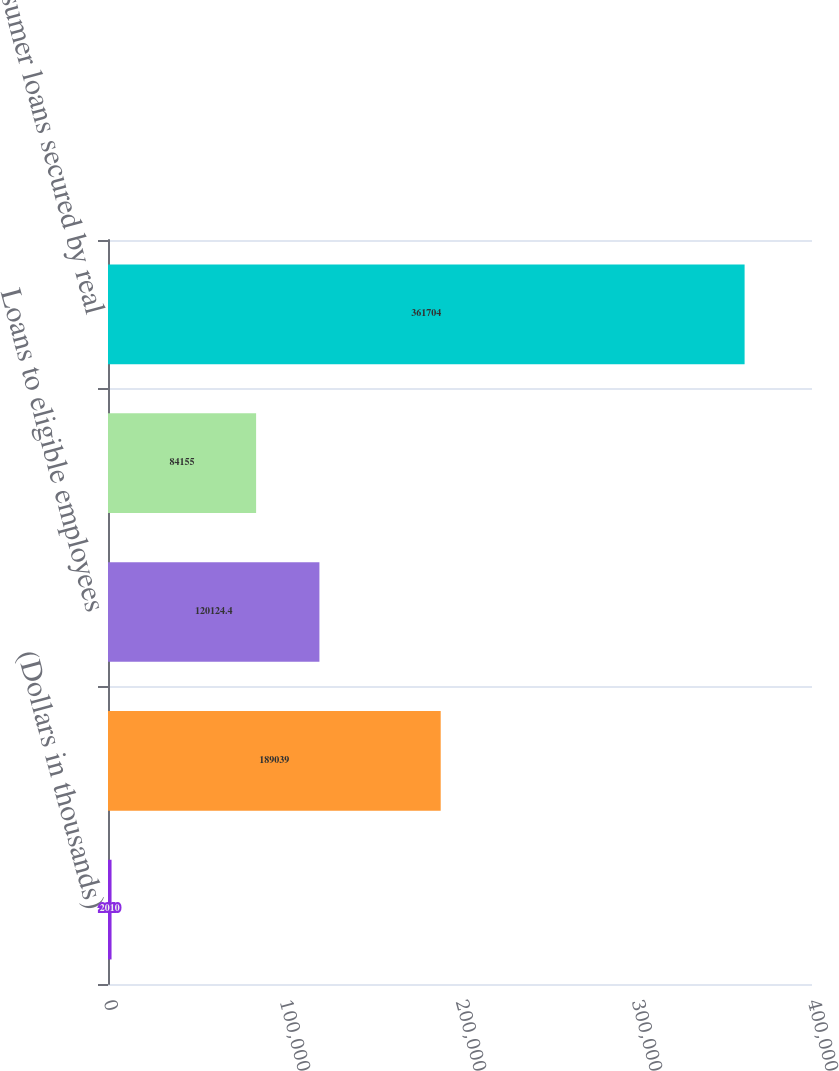<chart> <loc_0><loc_0><loc_500><loc_500><bar_chart><fcel>(Dollars in thousands)<fcel>Loans for personal residences<fcel>Loans to eligible employees<fcel>Home equity lines of credit<fcel>Consumer loans secured by real<nl><fcel>2010<fcel>189039<fcel>120124<fcel>84155<fcel>361704<nl></chart> 